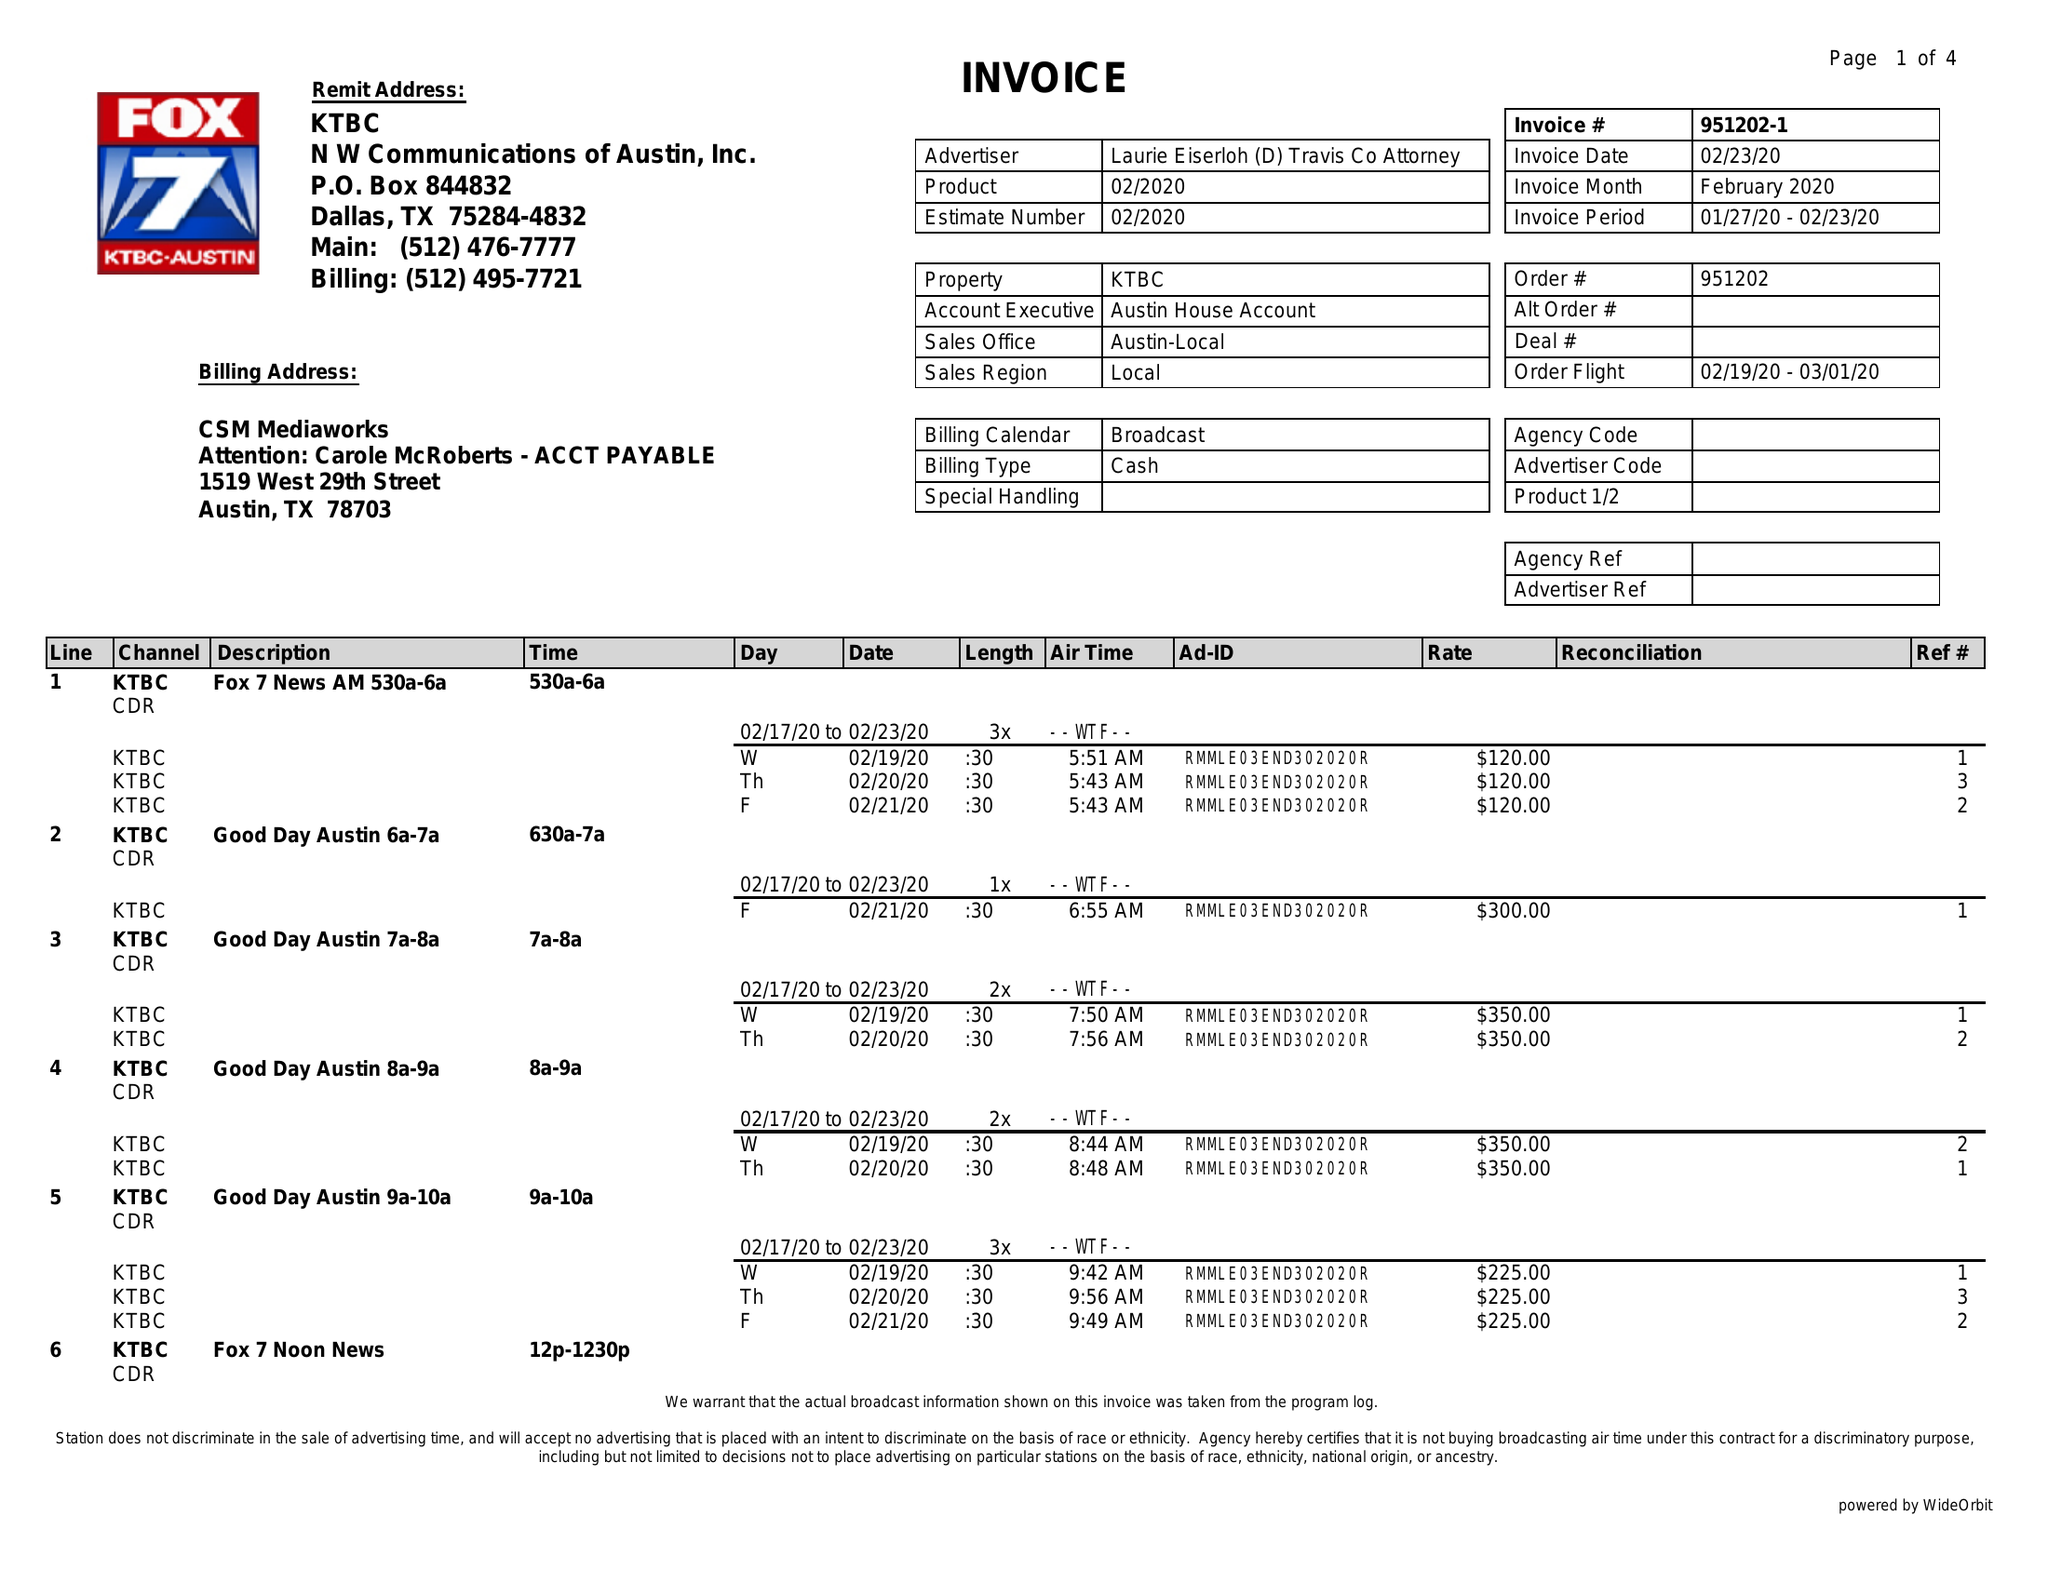What is the value for the flight_from?
Answer the question using a single word or phrase. 02/19/20 